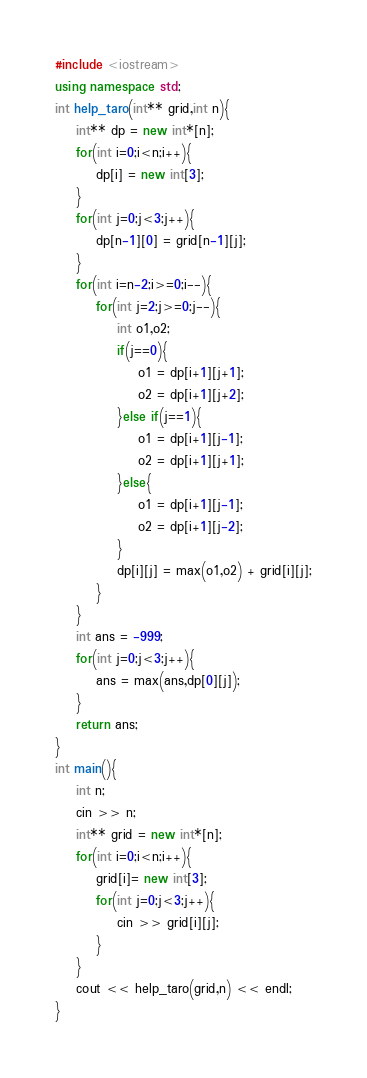Convert code to text. <code><loc_0><loc_0><loc_500><loc_500><_C++_>#include <iostream>
using namespace std;
int help_taro(int** grid,int n){
	int** dp = new int*[n];
	for(int i=0;i<n;i++){
		dp[i] = new int[3];
	}
	for(int j=0;j<3;j++){
		dp[n-1][0] = grid[n-1][j];
	}
	for(int i=n-2;i>=0;i--){
		for(int j=2;j>=0;j--){
			int o1,o2;
			if(j==0){
				o1 = dp[i+1][j+1];
				o2 = dp[i+1][j+2];
			}else if(j==1){
				o1 = dp[i+1][j-1];
				o2 = dp[i+1][j+1];
			}else{
				o1 = dp[i+1][j-1];
				o2 = dp[i+1][j-2];
			}
			dp[i][j] = max(o1,o2) + grid[i][j];
		}
	}
	int ans = -999;
	for(int j=0;j<3;j++){
		ans = max(ans,dp[0][j]);
	}
	return ans;
}
int main(){
	int n;
	cin >> n;
	int** grid = new int*[n];
	for(int i=0;i<n;i++){
		grid[i]= new int[3];
		for(int j=0;j<3;j++){
			cin >> grid[i][j];
		}
	}
	cout << help_taro(grid,n) << endl;
}</code> 